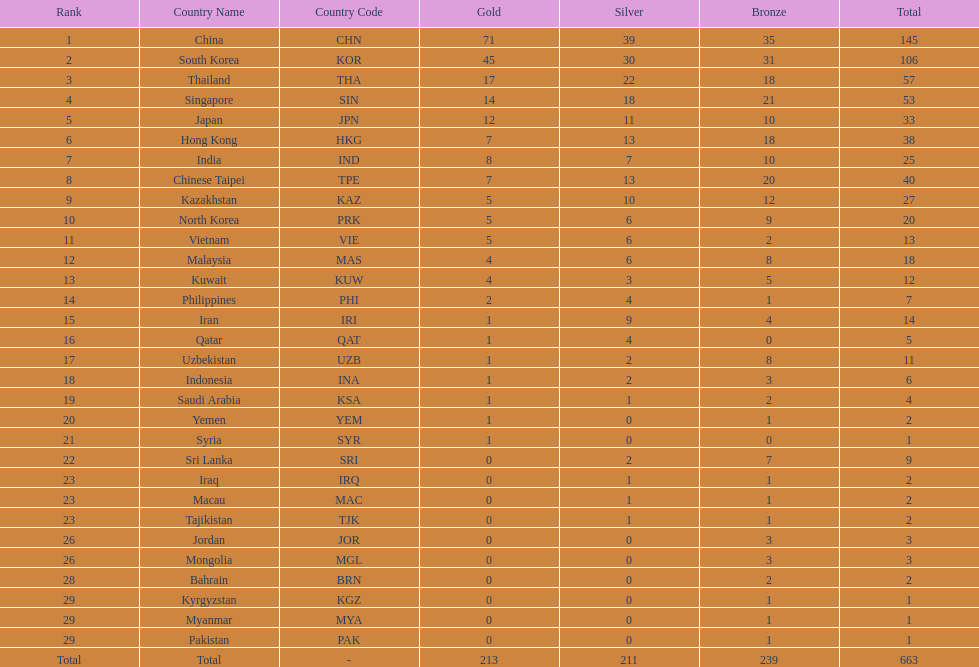How many nations earned at least ten bronze medals? 9. 